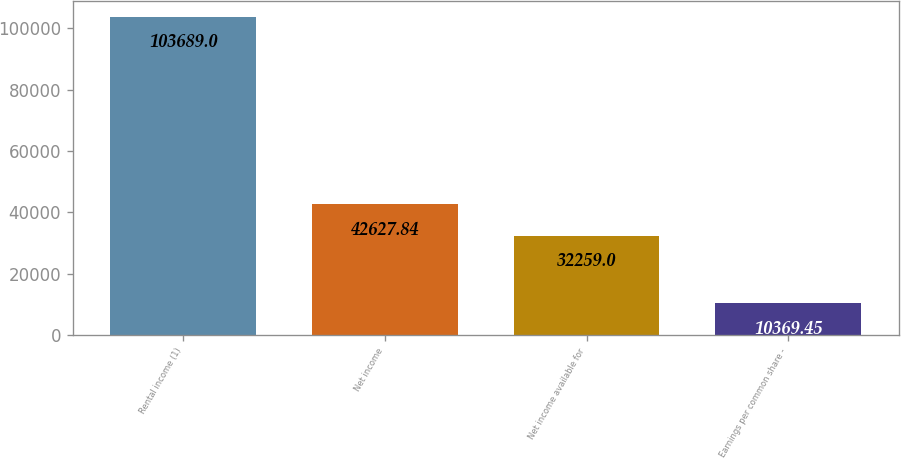<chart> <loc_0><loc_0><loc_500><loc_500><bar_chart><fcel>Rental income (1)<fcel>Net income<fcel>Net income available for<fcel>Earnings per common share -<nl><fcel>103689<fcel>42627.8<fcel>32259<fcel>10369.5<nl></chart> 